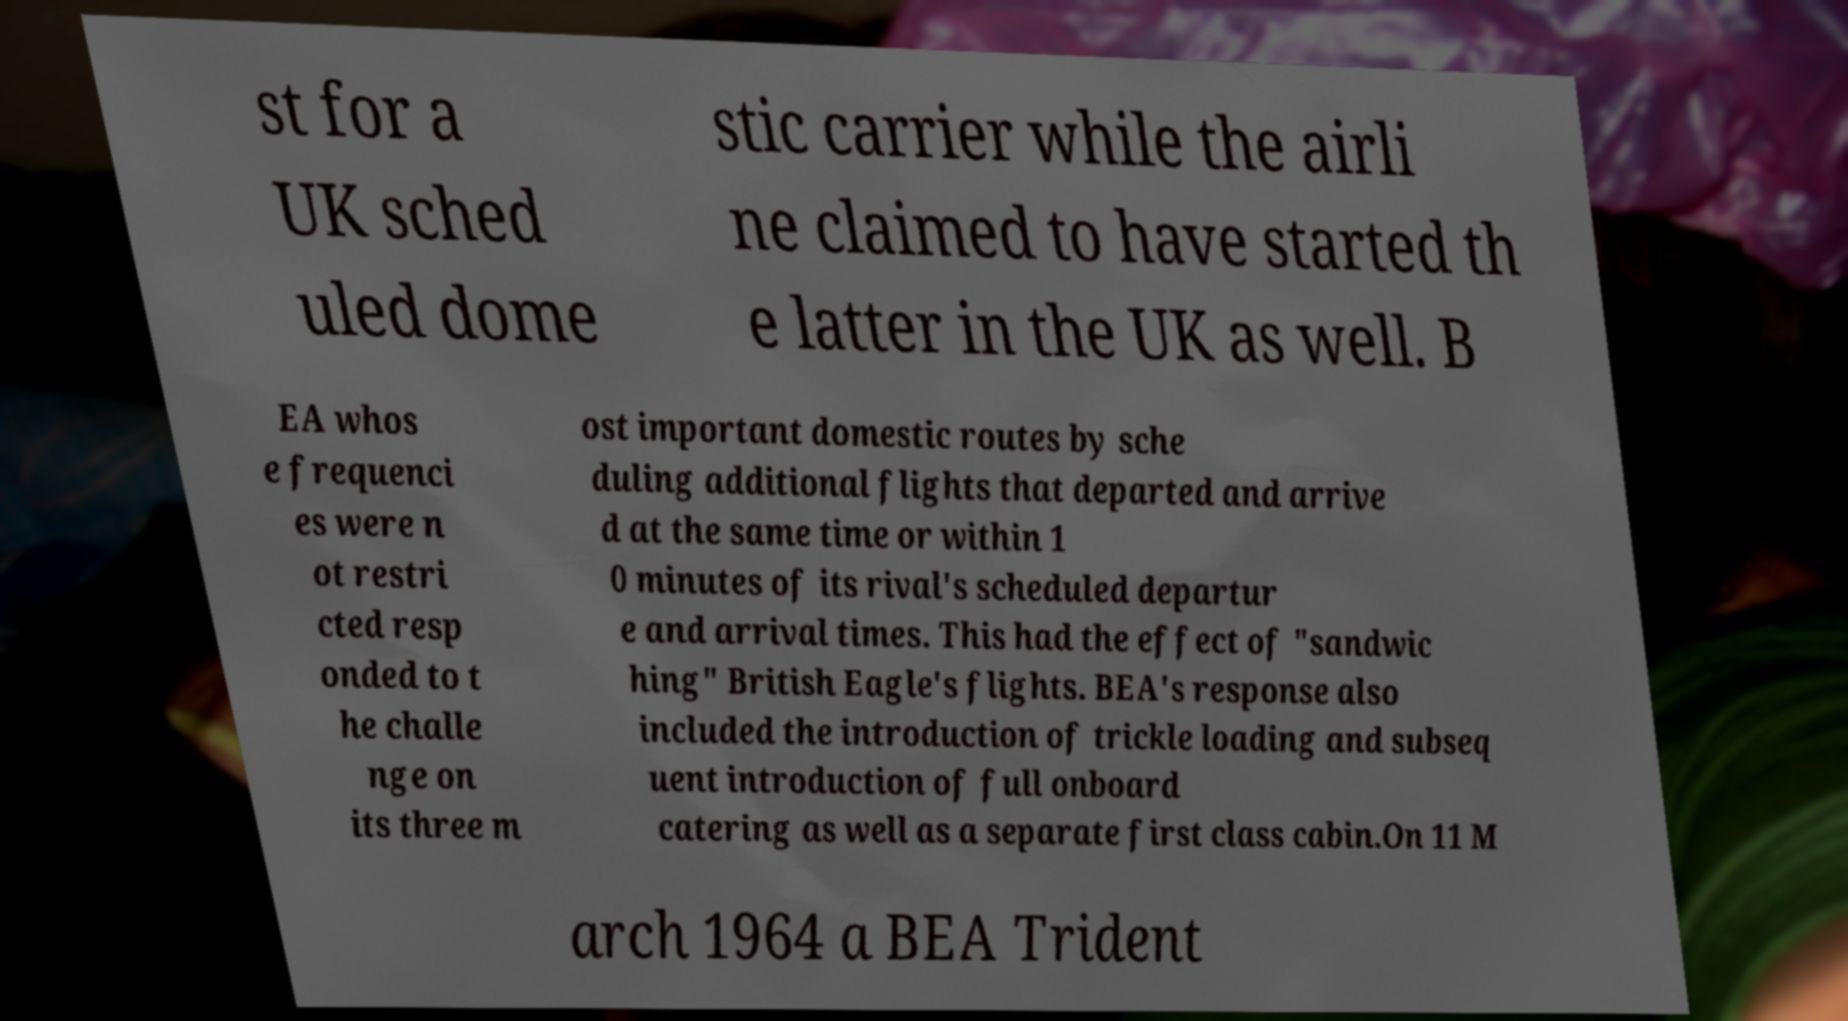Could you extract and type out the text from this image? st for a UK sched uled dome stic carrier while the airli ne claimed to have started th e latter in the UK as well. B EA whos e frequenci es were n ot restri cted resp onded to t he challe nge on its three m ost important domestic routes by sche duling additional flights that departed and arrive d at the same time or within 1 0 minutes of its rival's scheduled departur e and arrival times. This had the effect of "sandwic hing" British Eagle's flights. BEA's response also included the introduction of trickle loading and subseq uent introduction of full onboard catering as well as a separate first class cabin.On 11 M arch 1964 a BEA Trident 